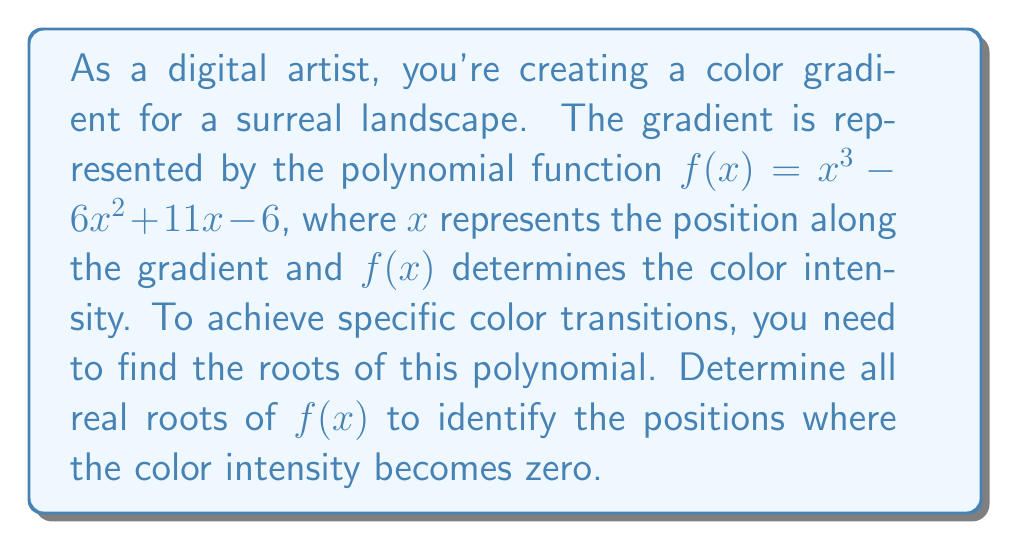Give your solution to this math problem. To find the roots of the polynomial $f(x) = x^3 - 6x^2 + 11x - 6$, we'll use the rational root theorem and synthetic division.

Step 1: List potential rational roots
The potential rational roots are the factors of the constant term (6):
$\pm 1, \pm 2, \pm 3, \pm 6$

Step 2: Use synthetic division to test these potential roots

Let's start with 1:

$$ \begin{array}{r}
1 \enclose{longdiv}{1 \quad -6 \quad 11 \quad -6} \\
\underline{1 \quad -5 \quad 6} \\
1 \quad -5 \quad 6 \quad 0
\end{array} $$

We found a root! $x = 1$ is a root of the polynomial.

Step 3: Factor out $(x - 1)$
$f(x) = (x - 1)(x^2 - 5x + 6)$

Step 4: Solve the quadratic equation $x^2 - 5x + 6 = 0$
Using the quadratic formula: $x = \frac{-b \pm \sqrt{b^2 - 4ac}}{2a}$

$x = \frac{5 \pm \sqrt{25 - 24}}{2} = \frac{5 \pm 1}{2}$

This gives us two more roots: $x = 3$ and $x = 2$

Therefore, the three roots of the polynomial are 1, 2, and 3.
Answer: $x = 1, 2, 3$ 